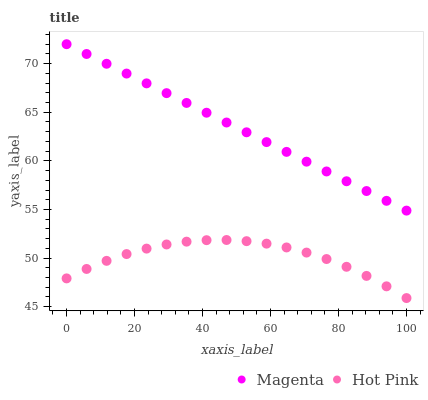Does Hot Pink have the minimum area under the curve?
Answer yes or no. Yes. Does Magenta have the maximum area under the curve?
Answer yes or no. Yes. Does Hot Pink have the maximum area under the curve?
Answer yes or no. No. Is Magenta the smoothest?
Answer yes or no. Yes. Is Hot Pink the roughest?
Answer yes or no. Yes. Is Hot Pink the smoothest?
Answer yes or no. No. Does Hot Pink have the lowest value?
Answer yes or no. Yes. Does Magenta have the highest value?
Answer yes or no. Yes. Does Hot Pink have the highest value?
Answer yes or no. No. Is Hot Pink less than Magenta?
Answer yes or no. Yes. Is Magenta greater than Hot Pink?
Answer yes or no. Yes. Does Hot Pink intersect Magenta?
Answer yes or no. No. 